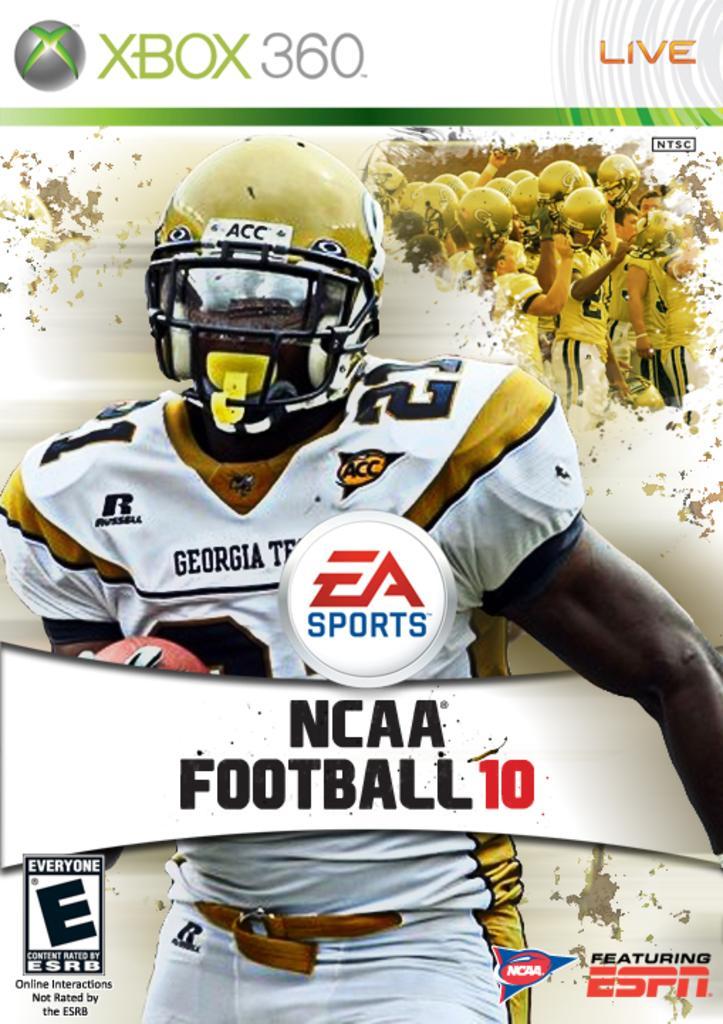Can you describe this image briefly? In this picture I can see a poster, there are logos, words, numbers and images on the poster. 